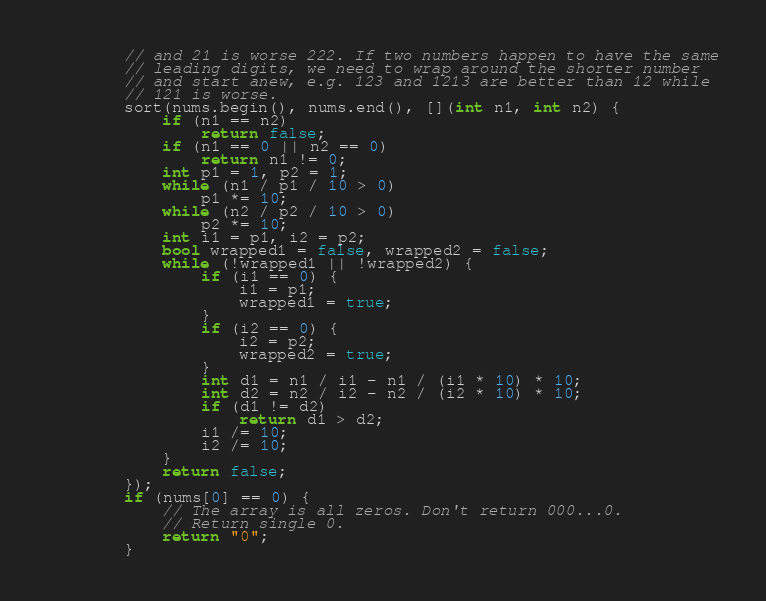<code> <loc_0><loc_0><loc_500><loc_500><_C++_>		// and 21 is worse 222. If two numbers happen to have the same
		// leading digits, we need to wrap around the shorter number
		// and start anew, e.g. 123 and 1213 are better than 12 while
		// 121 is worse.
		sort(nums.begin(), nums.end(), [](int n1, int n2) {
			if (n1 == n2)
				return false;
			if (n1 == 0 || n2 == 0)
				return n1 != 0;
			int p1 = 1, p2 = 1;
			while (n1 / p1 / 10 > 0)
				p1 *= 10;
			while (n2 / p2 / 10 > 0)
				p2 *= 10;
			int i1 = p1, i2 = p2;
			bool wrapped1 = false, wrapped2 = false;
			while (!wrapped1 || !wrapped2) {
				if (i1 == 0) {
					i1 = p1;
					wrapped1 = true;
				}
				if (i2 == 0) {
					i2 = p2;
					wrapped2 = true;
				}
				int d1 = n1 / i1 - n1 / (i1 * 10) * 10;
				int d2 = n2 / i2 - n2 / (i2 * 10) * 10;
				if (d1 != d2)
					return d1 > d2;
				i1 /= 10;
				i2 /= 10;
			}
			return false;
		});
		if (nums[0] == 0) {
			// The array is all zeros. Don't return 000...0.
			// Return single 0.
			return "0";
		}</code> 